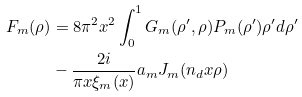Convert formula to latex. <formula><loc_0><loc_0><loc_500><loc_500>F _ { m } ( \rho ) & = 8 \pi ^ { 2 } x ^ { 2 } \int _ { 0 } ^ { 1 } G _ { m } ( \rho ^ { \prime } , \rho ) P _ { m } ( \rho ^ { \prime } ) \rho ^ { \prime } d \rho ^ { \prime } \\ & - \frac { 2 i } { \pi x \xi _ { m } ( x ) } a _ { m } J _ { m } ( n _ { d } x \rho )</formula> 